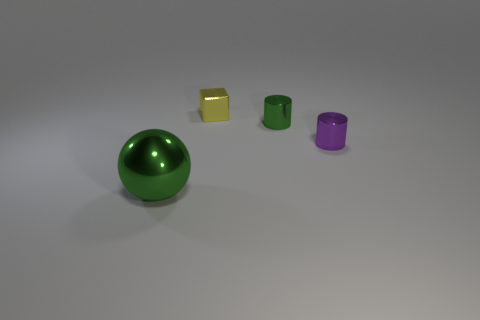What size is the cylinder that is the same color as the big sphere?
Keep it short and to the point. Small. There is a metallic object that is behind the green metal object behind the large green metal thing; is there a metallic thing that is on the left side of it?
Give a very brief answer. Yes. Are there fewer metallic spheres than big red shiny blocks?
Keep it short and to the point. No. Does the green thing to the right of the large green shiny ball have the same material as the small object in front of the small green metallic object?
Your answer should be compact. Yes. Are there fewer blocks in front of the tiny cube than gray cylinders?
Keep it short and to the point. No. There is a green thing on the right side of the large green ball; how many tiny cubes are in front of it?
Ensure brevity in your answer.  0. How big is the thing that is both to the right of the tiny cube and left of the purple object?
Offer a terse response. Small. Are there fewer big green metallic objects that are to the right of the yellow shiny object than small green cylinders right of the big green metal object?
Make the answer very short. Yes. What is the color of the tiny shiny object that is in front of the tiny cube and left of the purple metallic thing?
Ensure brevity in your answer.  Green. What number of other objects are the same color as the shiny sphere?
Offer a terse response. 1. 